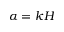Convert formula to latex. <formula><loc_0><loc_0><loc_500><loc_500>\alpha = k H</formula> 